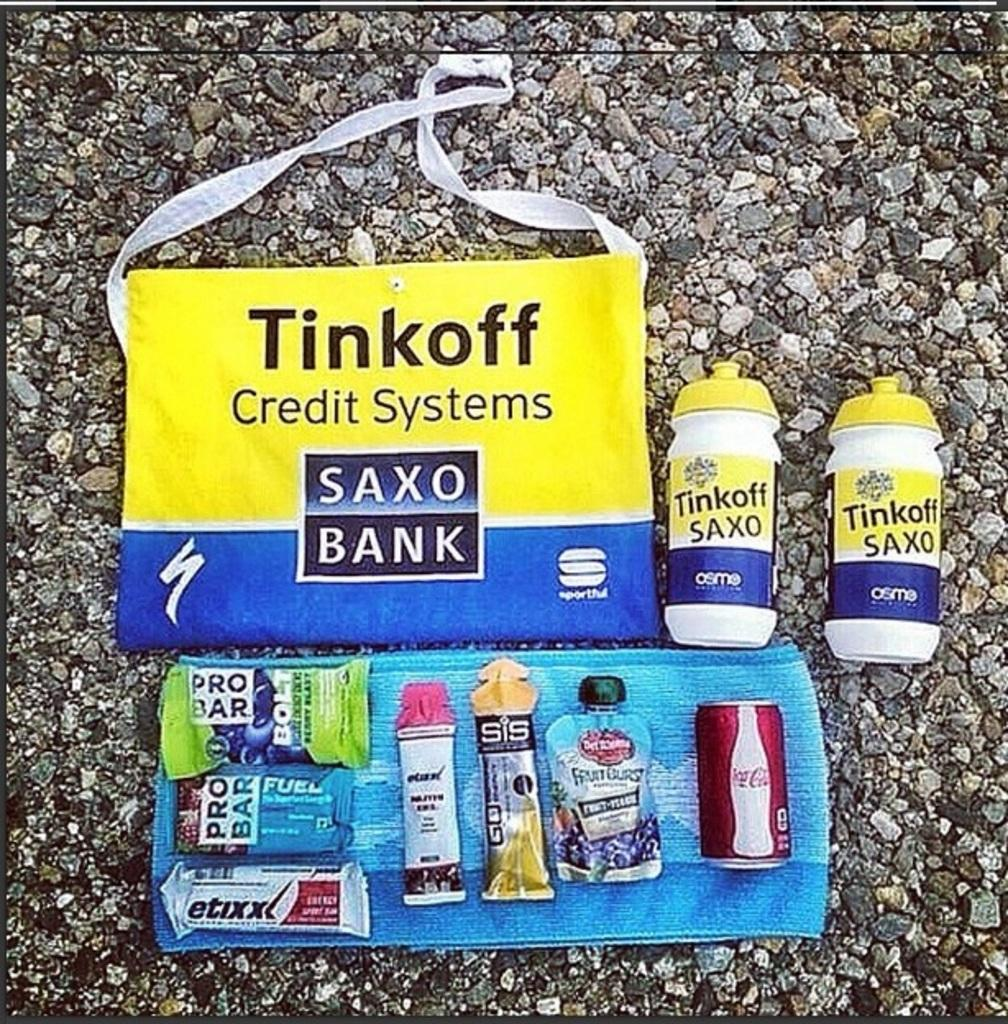<image>
Present a compact description of the photo's key features. Handbag with samples from a bank credit system 